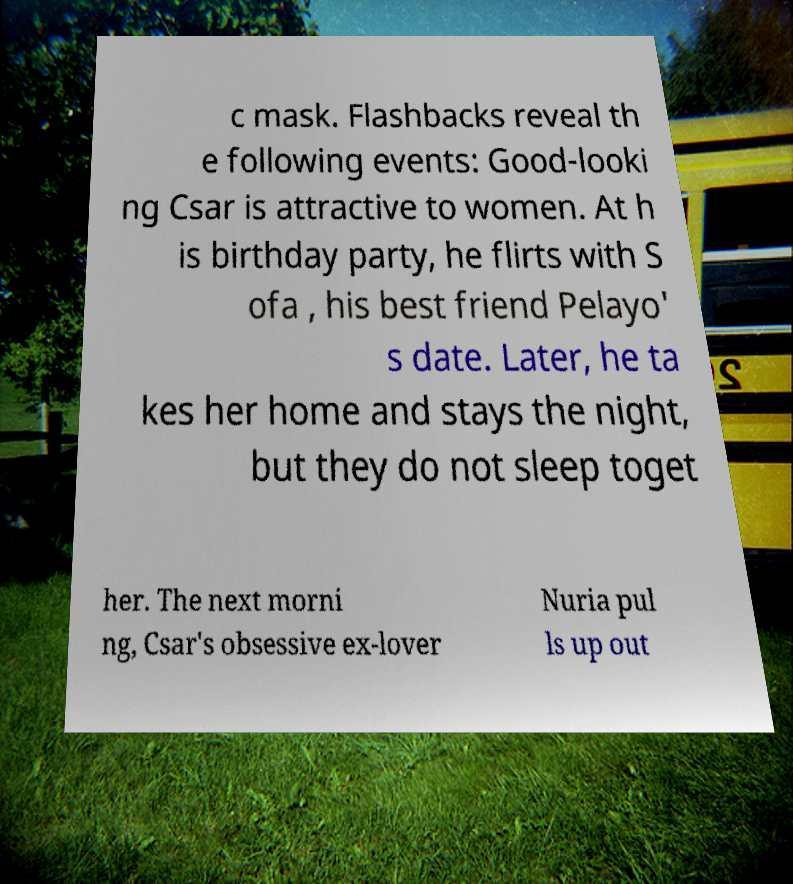For documentation purposes, I need the text within this image transcribed. Could you provide that? c mask. Flashbacks reveal th e following events: Good-looki ng Csar is attractive to women. At h is birthday party, he flirts with S ofa , his best friend Pelayo' s date. Later, he ta kes her home and stays the night, but they do not sleep toget her. The next morni ng, Csar's obsessive ex-lover Nuria pul ls up out 